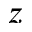Convert formula to latex. <formula><loc_0><loc_0><loc_500><loc_500>z</formula> 